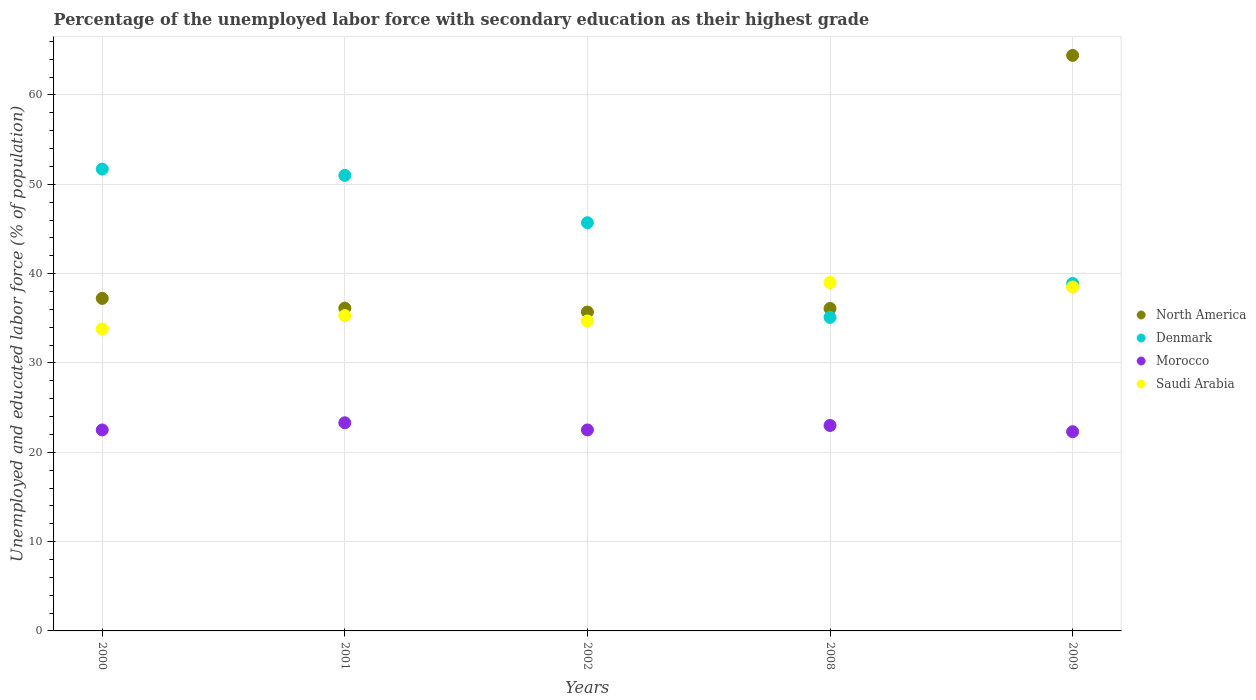Is the number of dotlines equal to the number of legend labels?
Offer a terse response. Yes. What is the percentage of the unemployed labor force with secondary education in Denmark in 2002?
Provide a short and direct response. 45.7. Across all years, what is the maximum percentage of the unemployed labor force with secondary education in Morocco?
Your response must be concise. 23.3. Across all years, what is the minimum percentage of the unemployed labor force with secondary education in North America?
Offer a terse response. 35.7. What is the total percentage of the unemployed labor force with secondary education in Morocco in the graph?
Provide a short and direct response. 113.6. What is the difference between the percentage of the unemployed labor force with secondary education in Denmark in 2008 and that in 2009?
Provide a succinct answer. -3.8. What is the difference between the percentage of the unemployed labor force with secondary education in Saudi Arabia in 2000 and the percentage of the unemployed labor force with secondary education in Morocco in 2008?
Give a very brief answer. 10.8. What is the average percentage of the unemployed labor force with secondary education in Morocco per year?
Provide a short and direct response. 22.72. In the year 2008, what is the difference between the percentage of the unemployed labor force with secondary education in Morocco and percentage of the unemployed labor force with secondary education in Saudi Arabia?
Ensure brevity in your answer.  -16. What is the ratio of the percentage of the unemployed labor force with secondary education in North America in 2000 to that in 2001?
Your response must be concise. 1.03. Is the percentage of the unemployed labor force with secondary education in Morocco in 2002 less than that in 2008?
Your response must be concise. Yes. What is the difference between the highest and the second highest percentage of the unemployed labor force with secondary education in North America?
Provide a succinct answer. 27.2. In how many years, is the percentage of the unemployed labor force with secondary education in North America greater than the average percentage of the unemployed labor force with secondary education in North America taken over all years?
Offer a terse response. 1. Is it the case that in every year, the sum of the percentage of the unemployed labor force with secondary education in Morocco and percentage of the unemployed labor force with secondary education in Saudi Arabia  is greater than the sum of percentage of the unemployed labor force with secondary education in Denmark and percentage of the unemployed labor force with secondary education in North America?
Your answer should be compact. No. Is it the case that in every year, the sum of the percentage of the unemployed labor force with secondary education in Morocco and percentage of the unemployed labor force with secondary education in North America  is greater than the percentage of the unemployed labor force with secondary education in Denmark?
Offer a terse response. Yes. Does the percentage of the unemployed labor force with secondary education in Saudi Arabia monotonically increase over the years?
Keep it short and to the point. No. Is the percentage of the unemployed labor force with secondary education in Denmark strictly greater than the percentage of the unemployed labor force with secondary education in North America over the years?
Your answer should be compact. No. What is the difference between two consecutive major ticks on the Y-axis?
Give a very brief answer. 10. Does the graph contain grids?
Offer a terse response. Yes. Where does the legend appear in the graph?
Give a very brief answer. Center right. How many legend labels are there?
Offer a very short reply. 4. How are the legend labels stacked?
Offer a very short reply. Vertical. What is the title of the graph?
Ensure brevity in your answer.  Percentage of the unemployed labor force with secondary education as their highest grade. What is the label or title of the X-axis?
Give a very brief answer. Years. What is the label or title of the Y-axis?
Your response must be concise. Unemployed and educated labor force (% of population). What is the Unemployed and educated labor force (% of population) of North America in 2000?
Provide a succinct answer. 37.23. What is the Unemployed and educated labor force (% of population) of Denmark in 2000?
Make the answer very short. 51.7. What is the Unemployed and educated labor force (% of population) of Saudi Arabia in 2000?
Make the answer very short. 33.8. What is the Unemployed and educated labor force (% of population) in North America in 2001?
Offer a very short reply. 36.14. What is the Unemployed and educated labor force (% of population) of Denmark in 2001?
Provide a succinct answer. 51. What is the Unemployed and educated labor force (% of population) in Morocco in 2001?
Ensure brevity in your answer.  23.3. What is the Unemployed and educated labor force (% of population) of Saudi Arabia in 2001?
Your response must be concise. 35.3. What is the Unemployed and educated labor force (% of population) of North America in 2002?
Make the answer very short. 35.7. What is the Unemployed and educated labor force (% of population) in Denmark in 2002?
Offer a terse response. 45.7. What is the Unemployed and educated labor force (% of population) of Morocco in 2002?
Make the answer very short. 22.5. What is the Unemployed and educated labor force (% of population) of Saudi Arabia in 2002?
Provide a succinct answer. 34.7. What is the Unemployed and educated labor force (% of population) of North America in 2008?
Offer a very short reply. 36.1. What is the Unemployed and educated labor force (% of population) in Denmark in 2008?
Provide a short and direct response. 35.1. What is the Unemployed and educated labor force (% of population) of Morocco in 2008?
Make the answer very short. 23. What is the Unemployed and educated labor force (% of population) in Saudi Arabia in 2008?
Offer a very short reply. 39. What is the Unemployed and educated labor force (% of population) in North America in 2009?
Give a very brief answer. 64.43. What is the Unemployed and educated labor force (% of population) of Denmark in 2009?
Your response must be concise. 38.9. What is the Unemployed and educated labor force (% of population) in Morocco in 2009?
Provide a succinct answer. 22.3. What is the Unemployed and educated labor force (% of population) in Saudi Arabia in 2009?
Make the answer very short. 38.5. Across all years, what is the maximum Unemployed and educated labor force (% of population) in North America?
Give a very brief answer. 64.43. Across all years, what is the maximum Unemployed and educated labor force (% of population) of Denmark?
Provide a short and direct response. 51.7. Across all years, what is the maximum Unemployed and educated labor force (% of population) of Morocco?
Your answer should be compact. 23.3. Across all years, what is the maximum Unemployed and educated labor force (% of population) of Saudi Arabia?
Provide a succinct answer. 39. Across all years, what is the minimum Unemployed and educated labor force (% of population) of North America?
Offer a terse response. 35.7. Across all years, what is the minimum Unemployed and educated labor force (% of population) in Denmark?
Provide a succinct answer. 35.1. Across all years, what is the minimum Unemployed and educated labor force (% of population) of Morocco?
Offer a very short reply. 22.3. Across all years, what is the minimum Unemployed and educated labor force (% of population) of Saudi Arabia?
Your answer should be compact. 33.8. What is the total Unemployed and educated labor force (% of population) in North America in the graph?
Provide a succinct answer. 209.6. What is the total Unemployed and educated labor force (% of population) of Denmark in the graph?
Provide a short and direct response. 222.4. What is the total Unemployed and educated labor force (% of population) in Morocco in the graph?
Make the answer very short. 113.6. What is the total Unemployed and educated labor force (% of population) in Saudi Arabia in the graph?
Keep it short and to the point. 181.3. What is the difference between the Unemployed and educated labor force (% of population) in North America in 2000 and that in 2001?
Provide a short and direct response. 1.08. What is the difference between the Unemployed and educated labor force (% of population) of Denmark in 2000 and that in 2001?
Offer a very short reply. 0.7. What is the difference between the Unemployed and educated labor force (% of population) in Saudi Arabia in 2000 and that in 2001?
Provide a short and direct response. -1.5. What is the difference between the Unemployed and educated labor force (% of population) in North America in 2000 and that in 2002?
Your answer should be compact. 1.53. What is the difference between the Unemployed and educated labor force (% of population) in Saudi Arabia in 2000 and that in 2002?
Make the answer very short. -0.9. What is the difference between the Unemployed and educated labor force (% of population) of North America in 2000 and that in 2008?
Make the answer very short. 1.13. What is the difference between the Unemployed and educated labor force (% of population) of Denmark in 2000 and that in 2008?
Keep it short and to the point. 16.6. What is the difference between the Unemployed and educated labor force (% of population) in Morocco in 2000 and that in 2008?
Your answer should be very brief. -0.5. What is the difference between the Unemployed and educated labor force (% of population) in North America in 2000 and that in 2009?
Provide a succinct answer. -27.2. What is the difference between the Unemployed and educated labor force (% of population) in Denmark in 2000 and that in 2009?
Make the answer very short. 12.8. What is the difference between the Unemployed and educated labor force (% of population) in Morocco in 2000 and that in 2009?
Make the answer very short. 0.2. What is the difference between the Unemployed and educated labor force (% of population) of Saudi Arabia in 2000 and that in 2009?
Your answer should be compact. -4.7. What is the difference between the Unemployed and educated labor force (% of population) of North America in 2001 and that in 2002?
Your answer should be compact. 0.44. What is the difference between the Unemployed and educated labor force (% of population) in Morocco in 2001 and that in 2002?
Provide a succinct answer. 0.8. What is the difference between the Unemployed and educated labor force (% of population) of North America in 2001 and that in 2008?
Your response must be concise. 0.05. What is the difference between the Unemployed and educated labor force (% of population) in North America in 2001 and that in 2009?
Provide a succinct answer. -28.29. What is the difference between the Unemployed and educated labor force (% of population) in Morocco in 2001 and that in 2009?
Your answer should be compact. 1. What is the difference between the Unemployed and educated labor force (% of population) in Saudi Arabia in 2001 and that in 2009?
Offer a terse response. -3.2. What is the difference between the Unemployed and educated labor force (% of population) of North America in 2002 and that in 2008?
Your answer should be compact. -0.4. What is the difference between the Unemployed and educated labor force (% of population) of North America in 2002 and that in 2009?
Make the answer very short. -28.73. What is the difference between the Unemployed and educated labor force (% of population) of Saudi Arabia in 2002 and that in 2009?
Make the answer very short. -3.8. What is the difference between the Unemployed and educated labor force (% of population) of North America in 2008 and that in 2009?
Ensure brevity in your answer.  -28.33. What is the difference between the Unemployed and educated labor force (% of population) in Denmark in 2008 and that in 2009?
Make the answer very short. -3.8. What is the difference between the Unemployed and educated labor force (% of population) in Morocco in 2008 and that in 2009?
Give a very brief answer. 0.7. What is the difference between the Unemployed and educated labor force (% of population) in North America in 2000 and the Unemployed and educated labor force (% of population) in Denmark in 2001?
Your response must be concise. -13.77. What is the difference between the Unemployed and educated labor force (% of population) in North America in 2000 and the Unemployed and educated labor force (% of population) in Morocco in 2001?
Provide a short and direct response. 13.93. What is the difference between the Unemployed and educated labor force (% of population) in North America in 2000 and the Unemployed and educated labor force (% of population) in Saudi Arabia in 2001?
Your answer should be very brief. 1.93. What is the difference between the Unemployed and educated labor force (% of population) of Denmark in 2000 and the Unemployed and educated labor force (% of population) of Morocco in 2001?
Make the answer very short. 28.4. What is the difference between the Unemployed and educated labor force (% of population) of Denmark in 2000 and the Unemployed and educated labor force (% of population) of Saudi Arabia in 2001?
Your response must be concise. 16.4. What is the difference between the Unemployed and educated labor force (% of population) in North America in 2000 and the Unemployed and educated labor force (% of population) in Denmark in 2002?
Your response must be concise. -8.47. What is the difference between the Unemployed and educated labor force (% of population) in North America in 2000 and the Unemployed and educated labor force (% of population) in Morocco in 2002?
Provide a short and direct response. 14.73. What is the difference between the Unemployed and educated labor force (% of population) in North America in 2000 and the Unemployed and educated labor force (% of population) in Saudi Arabia in 2002?
Offer a terse response. 2.53. What is the difference between the Unemployed and educated labor force (% of population) of Denmark in 2000 and the Unemployed and educated labor force (% of population) of Morocco in 2002?
Offer a very short reply. 29.2. What is the difference between the Unemployed and educated labor force (% of population) of Morocco in 2000 and the Unemployed and educated labor force (% of population) of Saudi Arabia in 2002?
Offer a very short reply. -12.2. What is the difference between the Unemployed and educated labor force (% of population) of North America in 2000 and the Unemployed and educated labor force (% of population) of Denmark in 2008?
Provide a short and direct response. 2.13. What is the difference between the Unemployed and educated labor force (% of population) in North America in 2000 and the Unemployed and educated labor force (% of population) in Morocco in 2008?
Ensure brevity in your answer.  14.23. What is the difference between the Unemployed and educated labor force (% of population) of North America in 2000 and the Unemployed and educated labor force (% of population) of Saudi Arabia in 2008?
Provide a short and direct response. -1.77. What is the difference between the Unemployed and educated labor force (% of population) of Denmark in 2000 and the Unemployed and educated labor force (% of population) of Morocco in 2008?
Give a very brief answer. 28.7. What is the difference between the Unemployed and educated labor force (% of population) of Morocco in 2000 and the Unemployed and educated labor force (% of population) of Saudi Arabia in 2008?
Keep it short and to the point. -16.5. What is the difference between the Unemployed and educated labor force (% of population) of North America in 2000 and the Unemployed and educated labor force (% of population) of Denmark in 2009?
Your answer should be compact. -1.67. What is the difference between the Unemployed and educated labor force (% of population) of North America in 2000 and the Unemployed and educated labor force (% of population) of Morocco in 2009?
Ensure brevity in your answer.  14.93. What is the difference between the Unemployed and educated labor force (% of population) in North America in 2000 and the Unemployed and educated labor force (% of population) in Saudi Arabia in 2009?
Make the answer very short. -1.27. What is the difference between the Unemployed and educated labor force (% of population) in Denmark in 2000 and the Unemployed and educated labor force (% of population) in Morocco in 2009?
Offer a terse response. 29.4. What is the difference between the Unemployed and educated labor force (% of population) in Morocco in 2000 and the Unemployed and educated labor force (% of population) in Saudi Arabia in 2009?
Give a very brief answer. -16. What is the difference between the Unemployed and educated labor force (% of population) of North America in 2001 and the Unemployed and educated labor force (% of population) of Denmark in 2002?
Your response must be concise. -9.56. What is the difference between the Unemployed and educated labor force (% of population) of North America in 2001 and the Unemployed and educated labor force (% of population) of Morocco in 2002?
Make the answer very short. 13.64. What is the difference between the Unemployed and educated labor force (% of population) in North America in 2001 and the Unemployed and educated labor force (% of population) in Saudi Arabia in 2002?
Ensure brevity in your answer.  1.44. What is the difference between the Unemployed and educated labor force (% of population) of Denmark in 2001 and the Unemployed and educated labor force (% of population) of Morocco in 2002?
Your answer should be very brief. 28.5. What is the difference between the Unemployed and educated labor force (% of population) of North America in 2001 and the Unemployed and educated labor force (% of population) of Denmark in 2008?
Offer a very short reply. 1.04. What is the difference between the Unemployed and educated labor force (% of population) of North America in 2001 and the Unemployed and educated labor force (% of population) of Morocco in 2008?
Give a very brief answer. 13.14. What is the difference between the Unemployed and educated labor force (% of population) of North America in 2001 and the Unemployed and educated labor force (% of population) of Saudi Arabia in 2008?
Keep it short and to the point. -2.86. What is the difference between the Unemployed and educated labor force (% of population) of Denmark in 2001 and the Unemployed and educated labor force (% of population) of Saudi Arabia in 2008?
Keep it short and to the point. 12. What is the difference between the Unemployed and educated labor force (% of population) of Morocco in 2001 and the Unemployed and educated labor force (% of population) of Saudi Arabia in 2008?
Provide a succinct answer. -15.7. What is the difference between the Unemployed and educated labor force (% of population) in North America in 2001 and the Unemployed and educated labor force (% of population) in Denmark in 2009?
Give a very brief answer. -2.76. What is the difference between the Unemployed and educated labor force (% of population) of North America in 2001 and the Unemployed and educated labor force (% of population) of Morocco in 2009?
Your answer should be very brief. 13.84. What is the difference between the Unemployed and educated labor force (% of population) of North America in 2001 and the Unemployed and educated labor force (% of population) of Saudi Arabia in 2009?
Offer a terse response. -2.36. What is the difference between the Unemployed and educated labor force (% of population) in Denmark in 2001 and the Unemployed and educated labor force (% of population) in Morocco in 2009?
Make the answer very short. 28.7. What is the difference between the Unemployed and educated labor force (% of population) in Morocco in 2001 and the Unemployed and educated labor force (% of population) in Saudi Arabia in 2009?
Offer a terse response. -15.2. What is the difference between the Unemployed and educated labor force (% of population) in North America in 2002 and the Unemployed and educated labor force (% of population) in Denmark in 2008?
Provide a short and direct response. 0.6. What is the difference between the Unemployed and educated labor force (% of population) in North America in 2002 and the Unemployed and educated labor force (% of population) in Morocco in 2008?
Offer a terse response. 12.7. What is the difference between the Unemployed and educated labor force (% of population) in North America in 2002 and the Unemployed and educated labor force (% of population) in Saudi Arabia in 2008?
Your answer should be compact. -3.3. What is the difference between the Unemployed and educated labor force (% of population) in Denmark in 2002 and the Unemployed and educated labor force (% of population) in Morocco in 2008?
Offer a very short reply. 22.7. What is the difference between the Unemployed and educated labor force (% of population) in Denmark in 2002 and the Unemployed and educated labor force (% of population) in Saudi Arabia in 2008?
Make the answer very short. 6.7. What is the difference between the Unemployed and educated labor force (% of population) in Morocco in 2002 and the Unemployed and educated labor force (% of population) in Saudi Arabia in 2008?
Your answer should be very brief. -16.5. What is the difference between the Unemployed and educated labor force (% of population) in North America in 2002 and the Unemployed and educated labor force (% of population) in Denmark in 2009?
Provide a short and direct response. -3.2. What is the difference between the Unemployed and educated labor force (% of population) of North America in 2002 and the Unemployed and educated labor force (% of population) of Morocco in 2009?
Offer a terse response. 13.4. What is the difference between the Unemployed and educated labor force (% of population) of North America in 2002 and the Unemployed and educated labor force (% of population) of Saudi Arabia in 2009?
Offer a very short reply. -2.8. What is the difference between the Unemployed and educated labor force (% of population) in Denmark in 2002 and the Unemployed and educated labor force (% of population) in Morocco in 2009?
Your answer should be compact. 23.4. What is the difference between the Unemployed and educated labor force (% of population) in Morocco in 2002 and the Unemployed and educated labor force (% of population) in Saudi Arabia in 2009?
Your answer should be very brief. -16. What is the difference between the Unemployed and educated labor force (% of population) in North America in 2008 and the Unemployed and educated labor force (% of population) in Denmark in 2009?
Offer a very short reply. -2.8. What is the difference between the Unemployed and educated labor force (% of population) in North America in 2008 and the Unemployed and educated labor force (% of population) in Morocco in 2009?
Ensure brevity in your answer.  13.8. What is the difference between the Unemployed and educated labor force (% of population) of North America in 2008 and the Unemployed and educated labor force (% of population) of Saudi Arabia in 2009?
Offer a terse response. -2.4. What is the difference between the Unemployed and educated labor force (% of population) of Denmark in 2008 and the Unemployed and educated labor force (% of population) of Morocco in 2009?
Keep it short and to the point. 12.8. What is the difference between the Unemployed and educated labor force (% of population) in Denmark in 2008 and the Unemployed and educated labor force (% of population) in Saudi Arabia in 2009?
Make the answer very short. -3.4. What is the difference between the Unemployed and educated labor force (% of population) of Morocco in 2008 and the Unemployed and educated labor force (% of population) of Saudi Arabia in 2009?
Give a very brief answer. -15.5. What is the average Unemployed and educated labor force (% of population) of North America per year?
Your response must be concise. 41.92. What is the average Unemployed and educated labor force (% of population) in Denmark per year?
Keep it short and to the point. 44.48. What is the average Unemployed and educated labor force (% of population) of Morocco per year?
Make the answer very short. 22.72. What is the average Unemployed and educated labor force (% of population) in Saudi Arabia per year?
Provide a short and direct response. 36.26. In the year 2000, what is the difference between the Unemployed and educated labor force (% of population) of North America and Unemployed and educated labor force (% of population) of Denmark?
Keep it short and to the point. -14.47. In the year 2000, what is the difference between the Unemployed and educated labor force (% of population) of North America and Unemployed and educated labor force (% of population) of Morocco?
Your answer should be very brief. 14.73. In the year 2000, what is the difference between the Unemployed and educated labor force (% of population) of North America and Unemployed and educated labor force (% of population) of Saudi Arabia?
Provide a short and direct response. 3.43. In the year 2000, what is the difference between the Unemployed and educated labor force (% of population) of Denmark and Unemployed and educated labor force (% of population) of Morocco?
Provide a short and direct response. 29.2. In the year 2001, what is the difference between the Unemployed and educated labor force (% of population) in North America and Unemployed and educated labor force (% of population) in Denmark?
Give a very brief answer. -14.86. In the year 2001, what is the difference between the Unemployed and educated labor force (% of population) in North America and Unemployed and educated labor force (% of population) in Morocco?
Provide a short and direct response. 12.84. In the year 2001, what is the difference between the Unemployed and educated labor force (% of population) in North America and Unemployed and educated labor force (% of population) in Saudi Arabia?
Give a very brief answer. 0.84. In the year 2001, what is the difference between the Unemployed and educated labor force (% of population) in Denmark and Unemployed and educated labor force (% of population) in Morocco?
Keep it short and to the point. 27.7. In the year 2001, what is the difference between the Unemployed and educated labor force (% of population) of Morocco and Unemployed and educated labor force (% of population) of Saudi Arabia?
Offer a terse response. -12. In the year 2002, what is the difference between the Unemployed and educated labor force (% of population) of North America and Unemployed and educated labor force (% of population) of Denmark?
Provide a succinct answer. -10. In the year 2002, what is the difference between the Unemployed and educated labor force (% of population) of North America and Unemployed and educated labor force (% of population) of Morocco?
Keep it short and to the point. 13.2. In the year 2002, what is the difference between the Unemployed and educated labor force (% of population) of Denmark and Unemployed and educated labor force (% of population) of Morocco?
Keep it short and to the point. 23.2. In the year 2002, what is the difference between the Unemployed and educated labor force (% of population) in Denmark and Unemployed and educated labor force (% of population) in Saudi Arabia?
Provide a succinct answer. 11. In the year 2008, what is the difference between the Unemployed and educated labor force (% of population) in North America and Unemployed and educated labor force (% of population) in Morocco?
Offer a terse response. 13.1. In the year 2008, what is the difference between the Unemployed and educated labor force (% of population) of North America and Unemployed and educated labor force (% of population) of Saudi Arabia?
Your answer should be very brief. -2.9. In the year 2008, what is the difference between the Unemployed and educated labor force (% of population) in Denmark and Unemployed and educated labor force (% of population) in Saudi Arabia?
Your response must be concise. -3.9. In the year 2008, what is the difference between the Unemployed and educated labor force (% of population) in Morocco and Unemployed and educated labor force (% of population) in Saudi Arabia?
Offer a very short reply. -16. In the year 2009, what is the difference between the Unemployed and educated labor force (% of population) in North America and Unemployed and educated labor force (% of population) in Denmark?
Give a very brief answer. 25.53. In the year 2009, what is the difference between the Unemployed and educated labor force (% of population) of North America and Unemployed and educated labor force (% of population) of Morocco?
Make the answer very short. 42.13. In the year 2009, what is the difference between the Unemployed and educated labor force (% of population) in North America and Unemployed and educated labor force (% of population) in Saudi Arabia?
Offer a very short reply. 25.93. In the year 2009, what is the difference between the Unemployed and educated labor force (% of population) in Denmark and Unemployed and educated labor force (% of population) in Saudi Arabia?
Give a very brief answer. 0.4. In the year 2009, what is the difference between the Unemployed and educated labor force (% of population) of Morocco and Unemployed and educated labor force (% of population) of Saudi Arabia?
Provide a short and direct response. -16.2. What is the ratio of the Unemployed and educated labor force (% of population) in Denmark in 2000 to that in 2001?
Your answer should be compact. 1.01. What is the ratio of the Unemployed and educated labor force (% of population) of Morocco in 2000 to that in 2001?
Offer a very short reply. 0.97. What is the ratio of the Unemployed and educated labor force (% of population) in Saudi Arabia in 2000 to that in 2001?
Offer a terse response. 0.96. What is the ratio of the Unemployed and educated labor force (% of population) in North America in 2000 to that in 2002?
Offer a very short reply. 1.04. What is the ratio of the Unemployed and educated labor force (% of population) in Denmark in 2000 to that in 2002?
Give a very brief answer. 1.13. What is the ratio of the Unemployed and educated labor force (% of population) in Morocco in 2000 to that in 2002?
Keep it short and to the point. 1. What is the ratio of the Unemployed and educated labor force (% of population) of Saudi Arabia in 2000 to that in 2002?
Your response must be concise. 0.97. What is the ratio of the Unemployed and educated labor force (% of population) of North America in 2000 to that in 2008?
Offer a terse response. 1.03. What is the ratio of the Unemployed and educated labor force (% of population) in Denmark in 2000 to that in 2008?
Your answer should be very brief. 1.47. What is the ratio of the Unemployed and educated labor force (% of population) of Morocco in 2000 to that in 2008?
Provide a succinct answer. 0.98. What is the ratio of the Unemployed and educated labor force (% of population) of Saudi Arabia in 2000 to that in 2008?
Ensure brevity in your answer.  0.87. What is the ratio of the Unemployed and educated labor force (% of population) of North America in 2000 to that in 2009?
Provide a short and direct response. 0.58. What is the ratio of the Unemployed and educated labor force (% of population) in Denmark in 2000 to that in 2009?
Provide a succinct answer. 1.33. What is the ratio of the Unemployed and educated labor force (% of population) of Morocco in 2000 to that in 2009?
Keep it short and to the point. 1.01. What is the ratio of the Unemployed and educated labor force (% of population) of Saudi Arabia in 2000 to that in 2009?
Provide a short and direct response. 0.88. What is the ratio of the Unemployed and educated labor force (% of population) of North America in 2001 to that in 2002?
Keep it short and to the point. 1.01. What is the ratio of the Unemployed and educated labor force (% of population) in Denmark in 2001 to that in 2002?
Ensure brevity in your answer.  1.12. What is the ratio of the Unemployed and educated labor force (% of population) in Morocco in 2001 to that in 2002?
Make the answer very short. 1.04. What is the ratio of the Unemployed and educated labor force (% of population) in Saudi Arabia in 2001 to that in 2002?
Give a very brief answer. 1.02. What is the ratio of the Unemployed and educated labor force (% of population) in Denmark in 2001 to that in 2008?
Keep it short and to the point. 1.45. What is the ratio of the Unemployed and educated labor force (% of population) in Saudi Arabia in 2001 to that in 2008?
Provide a short and direct response. 0.91. What is the ratio of the Unemployed and educated labor force (% of population) of North America in 2001 to that in 2009?
Ensure brevity in your answer.  0.56. What is the ratio of the Unemployed and educated labor force (% of population) in Denmark in 2001 to that in 2009?
Make the answer very short. 1.31. What is the ratio of the Unemployed and educated labor force (% of population) of Morocco in 2001 to that in 2009?
Your answer should be very brief. 1.04. What is the ratio of the Unemployed and educated labor force (% of population) in Saudi Arabia in 2001 to that in 2009?
Provide a short and direct response. 0.92. What is the ratio of the Unemployed and educated labor force (% of population) in North America in 2002 to that in 2008?
Offer a very short reply. 0.99. What is the ratio of the Unemployed and educated labor force (% of population) in Denmark in 2002 to that in 2008?
Give a very brief answer. 1.3. What is the ratio of the Unemployed and educated labor force (% of population) of Morocco in 2002 to that in 2008?
Offer a terse response. 0.98. What is the ratio of the Unemployed and educated labor force (% of population) in Saudi Arabia in 2002 to that in 2008?
Provide a short and direct response. 0.89. What is the ratio of the Unemployed and educated labor force (% of population) in North America in 2002 to that in 2009?
Provide a succinct answer. 0.55. What is the ratio of the Unemployed and educated labor force (% of population) of Denmark in 2002 to that in 2009?
Keep it short and to the point. 1.17. What is the ratio of the Unemployed and educated labor force (% of population) of Saudi Arabia in 2002 to that in 2009?
Ensure brevity in your answer.  0.9. What is the ratio of the Unemployed and educated labor force (% of population) of North America in 2008 to that in 2009?
Your response must be concise. 0.56. What is the ratio of the Unemployed and educated labor force (% of population) in Denmark in 2008 to that in 2009?
Your answer should be very brief. 0.9. What is the ratio of the Unemployed and educated labor force (% of population) in Morocco in 2008 to that in 2009?
Offer a very short reply. 1.03. What is the ratio of the Unemployed and educated labor force (% of population) of Saudi Arabia in 2008 to that in 2009?
Your answer should be very brief. 1.01. What is the difference between the highest and the second highest Unemployed and educated labor force (% of population) in North America?
Your answer should be very brief. 27.2. What is the difference between the highest and the second highest Unemployed and educated labor force (% of population) in Denmark?
Offer a very short reply. 0.7. What is the difference between the highest and the second highest Unemployed and educated labor force (% of population) of Saudi Arabia?
Your answer should be very brief. 0.5. What is the difference between the highest and the lowest Unemployed and educated labor force (% of population) of North America?
Your answer should be compact. 28.73. What is the difference between the highest and the lowest Unemployed and educated labor force (% of population) in Denmark?
Your answer should be very brief. 16.6. What is the difference between the highest and the lowest Unemployed and educated labor force (% of population) of Morocco?
Keep it short and to the point. 1. What is the difference between the highest and the lowest Unemployed and educated labor force (% of population) of Saudi Arabia?
Your answer should be compact. 5.2. 